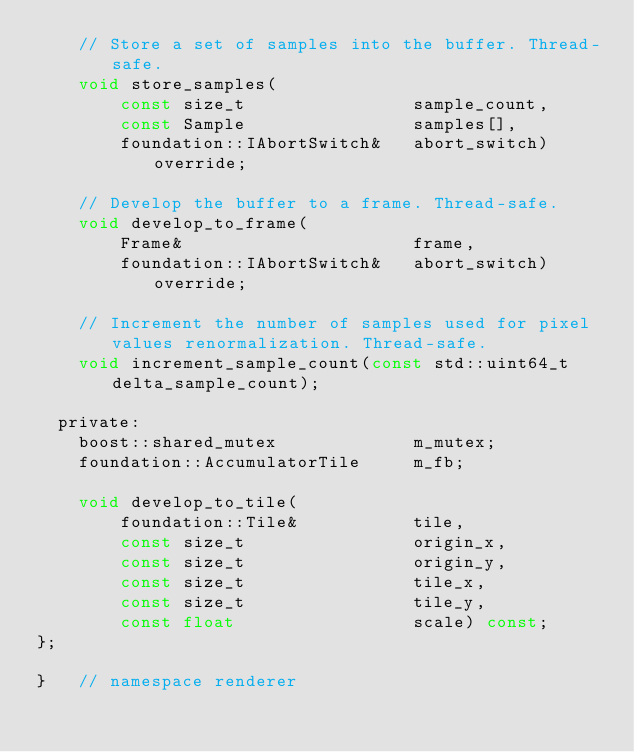<code> <loc_0><loc_0><loc_500><loc_500><_C_>    // Store a set of samples into the buffer. Thread-safe.
    void store_samples(
        const size_t                sample_count,
        const Sample                samples[],
        foundation::IAbortSwitch&   abort_switch) override;

    // Develop the buffer to a frame. Thread-safe.
    void develop_to_frame(
        Frame&                      frame,
        foundation::IAbortSwitch&   abort_switch) override;

    // Increment the number of samples used for pixel values renormalization. Thread-safe.
    void increment_sample_count(const std::uint64_t delta_sample_count);

  private:
    boost::shared_mutex             m_mutex;
    foundation::AccumulatorTile     m_fb;

    void develop_to_tile(
        foundation::Tile&           tile,
        const size_t                origin_x,
        const size_t                origin_y,
        const size_t                tile_x,
        const size_t                tile_y,
        const float                 scale) const;
};

}   // namespace renderer
</code> 